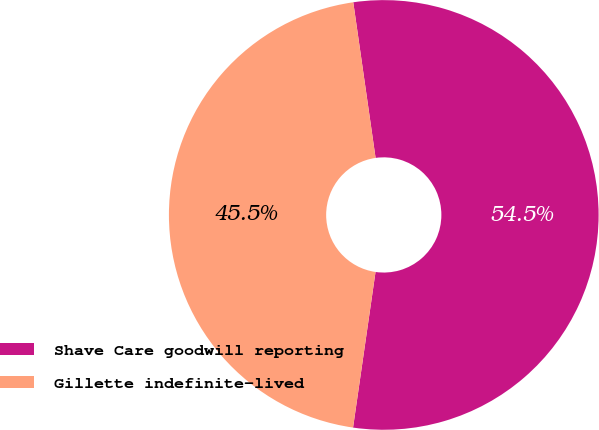Convert chart to OTSL. <chart><loc_0><loc_0><loc_500><loc_500><pie_chart><fcel>Shave Care goodwill reporting<fcel>Gillette indefinite-lived<nl><fcel>54.55%<fcel>45.45%<nl></chart> 